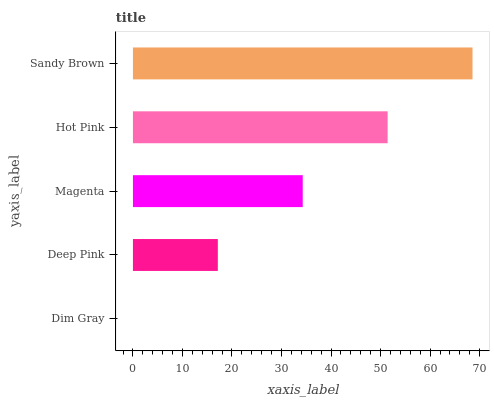Is Dim Gray the minimum?
Answer yes or no. Yes. Is Sandy Brown the maximum?
Answer yes or no. Yes. Is Deep Pink the minimum?
Answer yes or no. No. Is Deep Pink the maximum?
Answer yes or no. No. Is Deep Pink greater than Dim Gray?
Answer yes or no. Yes. Is Dim Gray less than Deep Pink?
Answer yes or no. Yes. Is Dim Gray greater than Deep Pink?
Answer yes or no. No. Is Deep Pink less than Dim Gray?
Answer yes or no. No. Is Magenta the high median?
Answer yes or no. Yes. Is Magenta the low median?
Answer yes or no. Yes. Is Dim Gray the high median?
Answer yes or no. No. Is Dim Gray the low median?
Answer yes or no. No. 